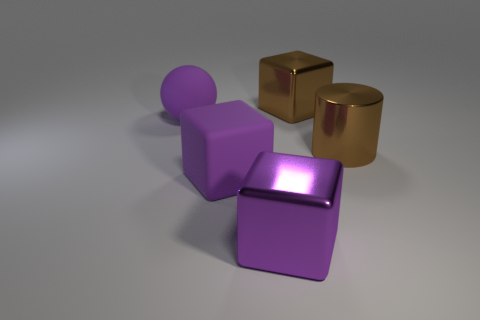Add 4 small red cylinders. How many objects exist? 9 Subtract all blocks. How many objects are left? 2 Subtract 0 yellow cubes. How many objects are left? 5 Subtract all big objects. Subtract all small red matte cylinders. How many objects are left? 0 Add 2 large purple things. How many large purple things are left? 5 Add 1 big cyan blocks. How many big cyan blocks exist? 1 